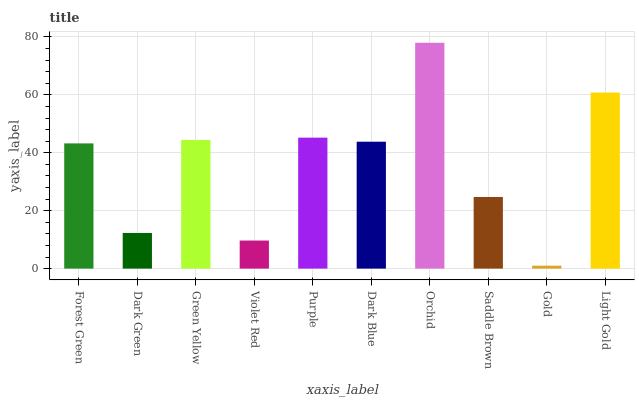Is Gold the minimum?
Answer yes or no. Yes. Is Orchid the maximum?
Answer yes or no. Yes. Is Dark Green the minimum?
Answer yes or no. No. Is Dark Green the maximum?
Answer yes or no. No. Is Forest Green greater than Dark Green?
Answer yes or no. Yes. Is Dark Green less than Forest Green?
Answer yes or no. Yes. Is Dark Green greater than Forest Green?
Answer yes or no. No. Is Forest Green less than Dark Green?
Answer yes or no. No. Is Dark Blue the high median?
Answer yes or no. Yes. Is Forest Green the low median?
Answer yes or no. Yes. Is Purple the high median?
Answer yes or no. No. Is Orchid the low median?
Answer yes or no. No. 